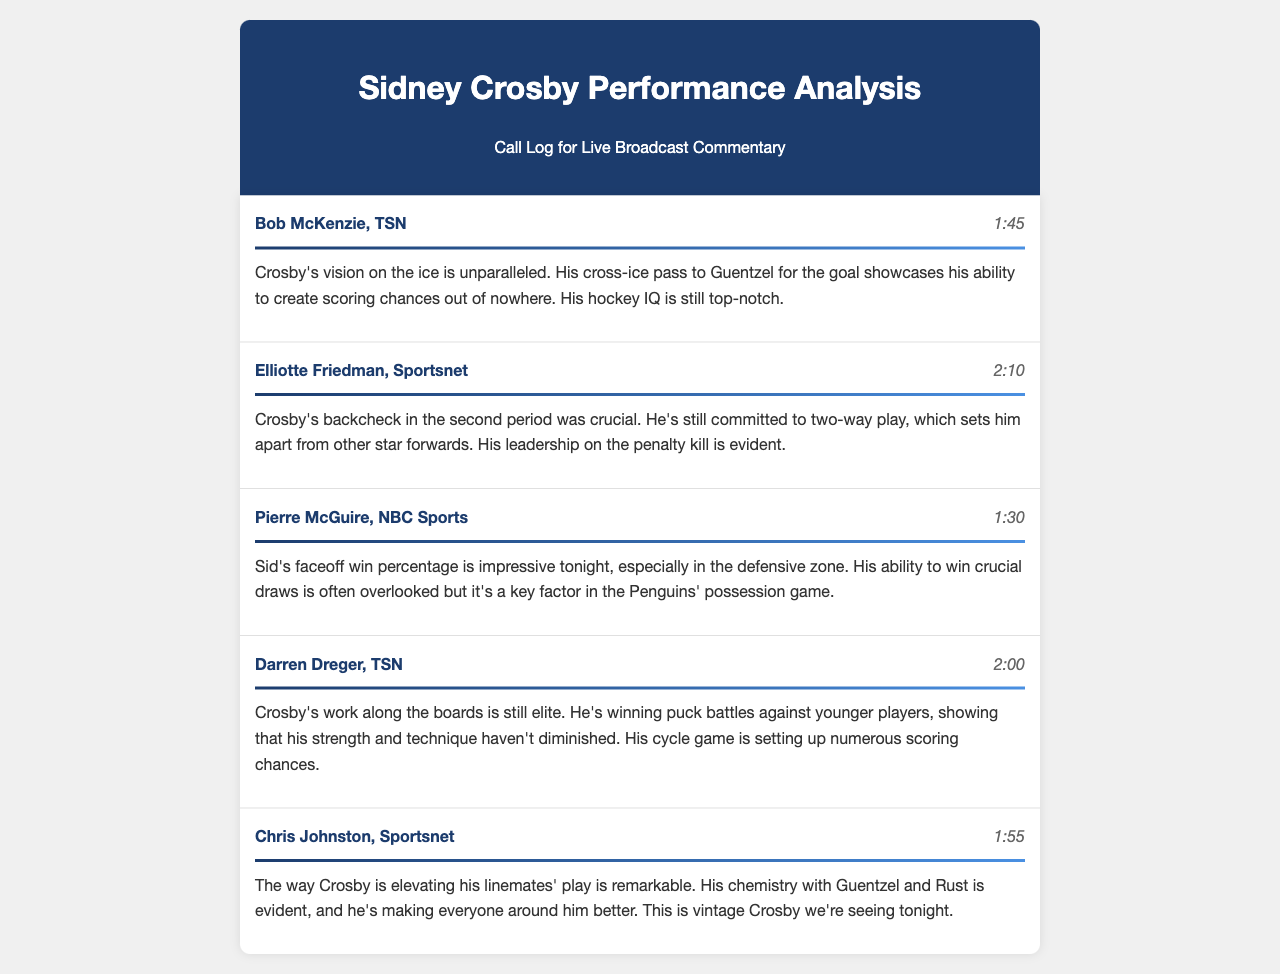What is the duration of the call with Bob McKenzie? The duration of the call with Bob McKenzie is listed at the end of the call entry.
Answer: 1:45 What was highlighted about Crosby's performance in the call with Elliotte Friedman? The call with Elliotte Friedman notes Crosby's commitment to two-way play during a backcheck in the second period.
Answer: Two-way play What percentage is Crosby's faceoff win noted as being impressive? The document mentions Crosby's faceoff win percentage specifically in the context of his performance tonight.
Answer: Impressive Who did Crosby make a cross-ice pass to for a goal? The document indicates that Crosby made a notable pass to a teammate for a goal, which is mentioned in Bob McKenzie's comments.
Answer: Guentzel What aspect of Crosby's game was described as "elite" in the call with Darren Dreger? The call mentions an impressive level of performance in relation to Crosby's work and skills along a specific part of the game.
Answer: Work along the boards Which hockey team is associated with Sidney Crosby in the document? The entire analysis revolves around Crosby's impact and play on his respective team during the game.
Answer: Penguins How many calls are summarized in the call log? The document provides a summary of various calls by different sports journalists commenting on Crosby's gameplay, which can be counted at the beginning.
Answer: Five 